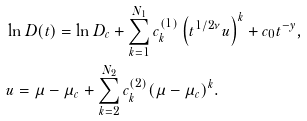Convert formula to latex. <formula><loc_0><loc_0><loc_500><loc_500>& \ln D ( t ) = \ln D _ { c } + \sum _ { k = 1 } ^ { N _ { 1 } } c ^ { ( 1 ) } _ { k } \left ( t ^ { 1 / 2 \nu } u \right ) ^ { k } + c _ { 0 } t ^ { - y } , \\ & u = \mu - \mu _ { c } + \sum _ { k = 2 } ^ { N _ { 2 } } c ^ { ( 2 ) } _ { k } ( \mu - \mu _ { c } ) ^ { k } .</formula> 